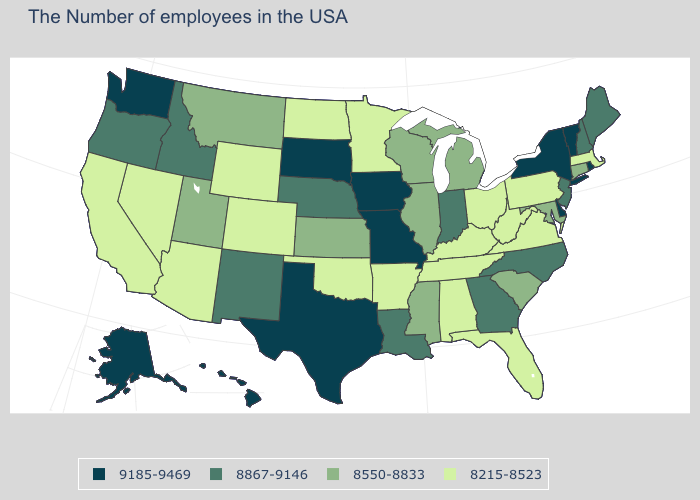Name the states that have a value in the range 8215-8523?
Give a very brief answer. Massachusetts, Pennsylvania, Virginia, West Virginia, Ohio, Florida, Kentucky, Alabama, Tennessee, Arkansas, Minnesota, Oklahoma, North Dakota, Wyoming, Colorado, Arizona, Nevada, California. Name the states that have a value in the range 8215-8523?
Be succinct. Massachusetts, Pennsylvania, Virginia, West Virginia, Ohio, Florida, Kentucky, Alabama, Tennessee, Arkansas, Minnesota, Oklahoma, North Dakota, Wyoming, Colorado, Arizona, Nevada, California. Which states hav the highest value in the West?
Concise answer only. Washington, Alaska, Hawaii. Among the states that border Tennessee , which have the highest value?
Be succinct. Missouri. Does the map have missing data?
Keep it brief. No. Does the map have missing data?
Give a very brief answer. No. Among the states that border Mississippi , does Louisiana have the lowest value?
Write a very short answer. No. Does the first symbol in the legend represent the smallest category?
Be succinct. No. Does Louisiana have the same value as Nebraska?
Short answer required. Yes. What is the value of Washington?
Short answer required. 9185-9469. Name the states that have a value in the range 8215-8523?
Give a very brief answer. Massachusetts, Pennsylvania, Virginia, West Virginia, Ohio, Florida, Kentucky, Alabama, Tennessee, Arkansas, Minnesota, Oklahoma, North Dakota, Wyoming, Colorado, Arizona, Nevada, California. What is the value of Hawaii?
Quick response, please. 9185-9469. What is the value of Texas?
Short answer required. 9185-9469. What is the value of Michigan?
Answer briefly. 8550-8833. Name the states that have a value in the range 9185-9469?
Keep it brief. Rhode Island, Vermont, New York, Delaware, Missouri, Iowa, Texas, South Dakota, Washington, Alaska, Hawaii. 